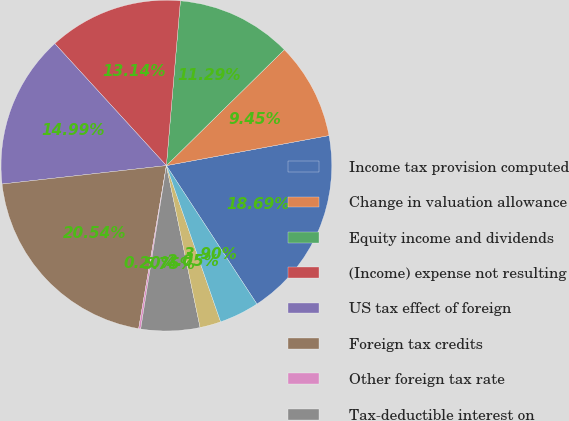Convert chart to OTSL. <chart><loc_0><loc_0><loc_500><loc_500><pie_chart><fcel>Income tax provision computed<fcel>Change in valuation allowance<fcel>Equity income and dividends<fcel>(Income) expense not resulting<fcel>US tax effect of foreign<fcel>Foreign tax credits<fcel>Other foreign tax rate<fcel>Tax-deductible interest on<fcel>State income taxes net of<fcel>Other net<nl><fcel>18.69%<fcel>9.45%<fcel>11.29%<fcel>13.14%<fcel>14.99%<fcel>20.54%<fcel>0.2%<fcel>5.75%<fcel>2.05%<fcel>3.9%<nl></chart> 